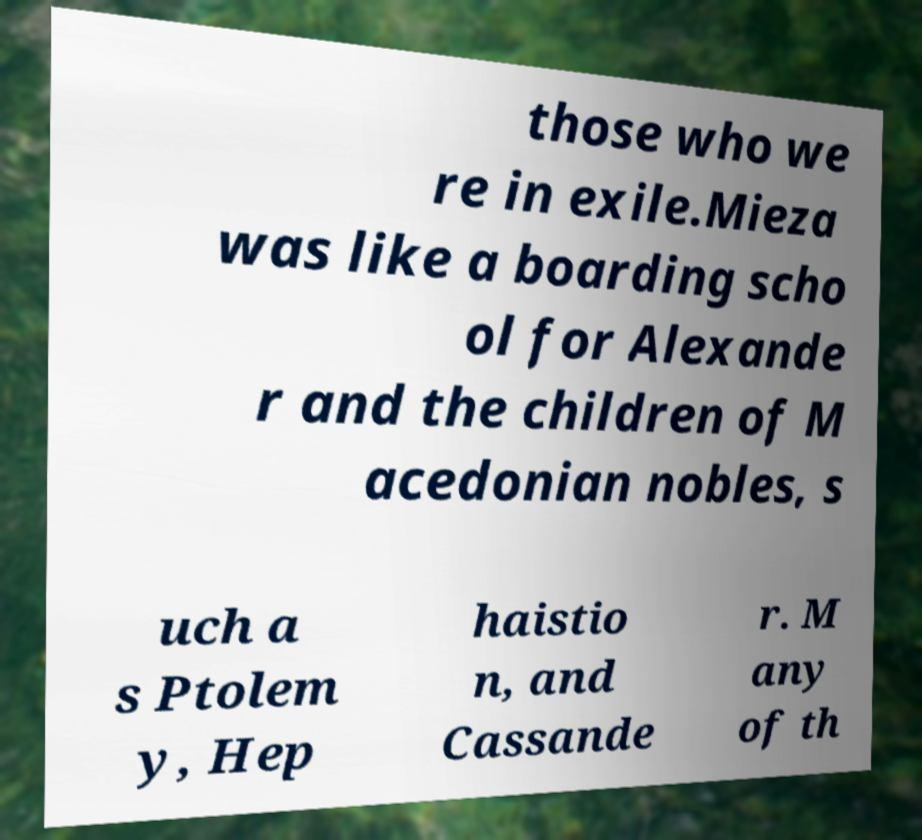Can you read and provide the text displayed in the image?This photo seems to have some interesting text. Can you extract and type it out for me? those who we re in exile.Mieza was like a boarding scho ol for Alexande r and the children of M acedonian nobles, s uch a s Ptolem y, Hep haistio n, and Cassande r. M any of th 